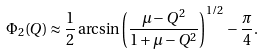<formula> <loc_0><loc_0><loc_500><loc_500>\Phi _ { 2 } ( Q ) \approx \frac { 1 } { 2 } \arcsin \left ( \frac { \mu - Q ^ { 2 } } { 1 + \mu - Q ^ { 2 } } \right ) ^ { 1 / 2 } - \frac { \pi } { 4 } .</formula> 